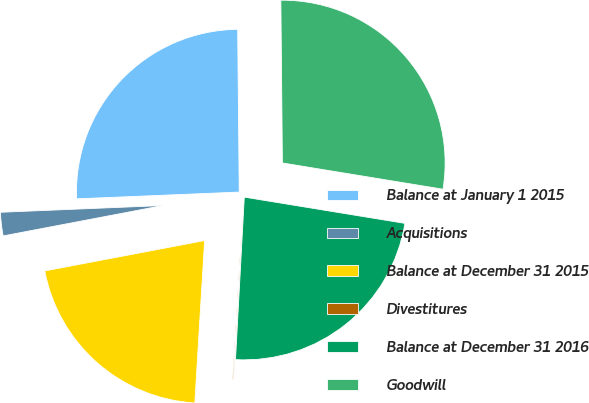Convert chart to OTSL. <chart><loc_0><loc_0><loc_500><loc_500><pie_chart><fcel>Balance at January 1 2015<fcel>Acquisitions<fcel>Balance at December 31 2015<fcel>Divestitures<fcel>Balance at December 31 2016<fcel>Goodwill<nl><fcel>25.51%<fcel>2.33%<fcel>21.05%<fcel>0.1%<fcel>23.28%<fcel>27.73%<nl></chart> 